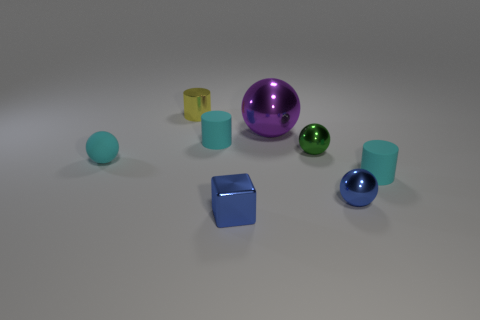Is there a pattern to the arrangement of the objects? The objects seem to be randomly placed without a discernible pattern. However, they are somewhat grouped by color, as the two blue-toned objects are near each other. 